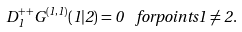Convert formula to latex. <formula><loc_0><loc_0><loc_500><loc_500>D _ { 1 } ^ { + + } G ^ { ( 1 , 1 ) } ( 1 | 2 ) = 0 \ \ f o r p o i n t s 1 \neq 2 .</formula> 